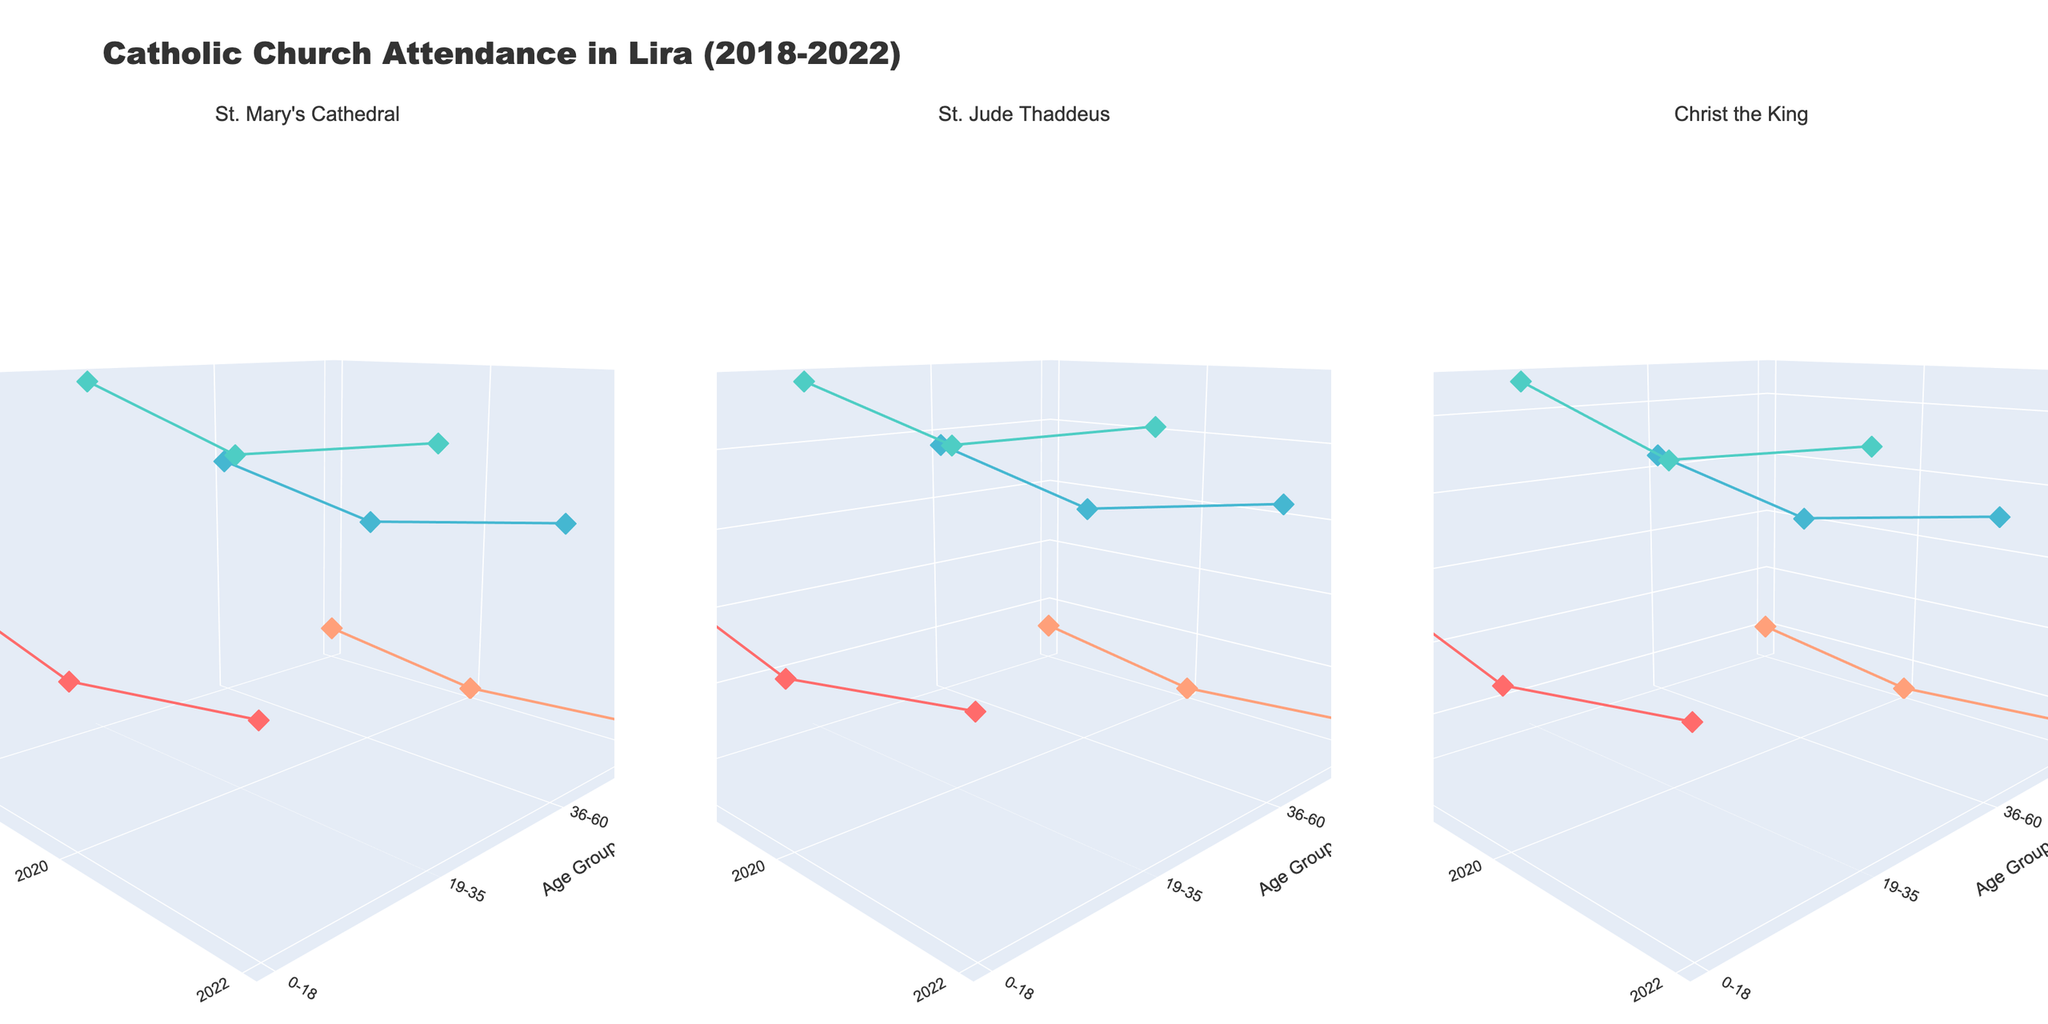What is the attendance for the age group 60+ at St. Mary's Cathedral in 2018? Look at the subplot for St. Mary's Cathedral and find the data point for the year 2018 and age group 60+. The attendance value is marked on the z-axis.
Answer: 210 What is the trend in attendance for the 0-18 age group across all parishes from 2018 to 2022? In each subplot, locate the markers and lines for the 0-18 age group across the years 2018, 2020, and 2022. For St. Mary's Cathedral, the trend is slightly decreasing then increasing (320 -> 290 -> 310). For St. Jude Thaddeus, it's decreasing (280 -> 250 -> 270). For Christ the King, it's decreasing then slightly increasing (300 -> 270 -> 290).
Answer: Decreasing then increasing trend Compare the attendance of 19-35 age group between St. Mary's Cathedral and Christ the King in 2020? Observe both the St. Mary's Cathedral and Christ the King subplots. Locate the 19-35 age group markers for the year 2020. For St. Mary's Cathedral, the attendance is 410, and for Christ the King, it is 380.
Answer: St. Mary's Cathedral has higher attendance (410 vs. 380) How did the attendance for the 36-60 age group change at St. Jude Thaddeus from 2018 to 2022? Look at the subplot for St. Jude Thaddeus, identify the 36-60 age group lines and markers over the years. The attendance goes from 340 in 2018 to 310 in 2020 and then to 330 in 2022.
Answer: Decreased then increased (340 -> 310 -> 330) Which parish had the highest attendance for the 19-35 age group in 2018? Check each subplot for the year 2018 and identify the markers for the 19-35 age group. For St. Mary's Cathedral, it's 450, for St. Jude Thaddeus, it's 390, and for Christ the King, it's 420.
Answer: St. Mary's Cathedral (450) What is the overall attendance trend for the 60+ age group at all parishes from 2018 to 2022? Review each subplot and observe the 60+ age group's attendance markers over the years. In 2018: 210 (St. Mary's Cathedral), 180 (St. Jude Thaddeus), 200 (Christ the King). In 2020: 190, 160, 180. In 2022: 200, 170, 190. The trend for St. Mary's Cathedral shows a slight decrease then increase (210 -> 190 -> 200), for St. Jude Thaddeus and Christ the King, a slight decrease followed by a small increase.
Answer: Slight decrease then increase 